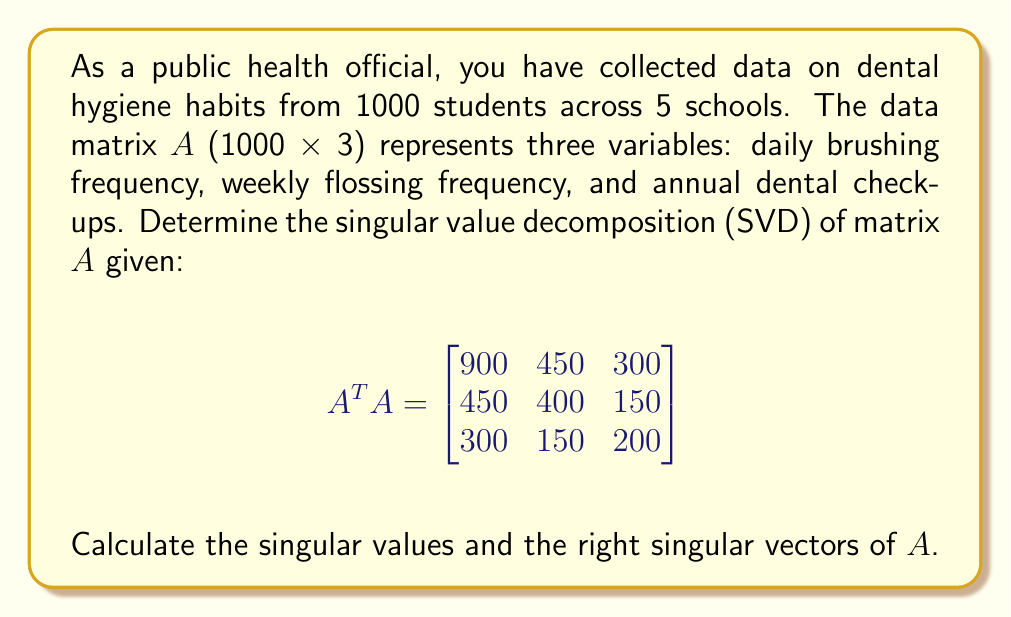Could you help me with this problem? To find the singular value decomposition of $A$, we need to follow these steps:

1) The singular values of $A$ are the square roots of the eigenvalues of $A^T A$.

2) Find the eigenvalues of $A^T A$ by solving the characteristic equation:
   $$\det(A^T A - \lambda I) = 0$$

3) Expand the determinant:
   $$\begin{vmatrix}
   900-\lambda & 450 & 300 \\
   450 & 400-\lambda & 150 \\
   300 & 150 & 200-\lambda
   \end{vmatrix} = 0$$

4) This yields the cubic equation:
   $$-\lambda^3 + 1500\lambda^2 - 517500\lambda + 45000000 = 0$$

5) Solving this equation (using a computer algebra system) gives the eigenvalues:
   $$\lambda_1 = 1200, \lambda_2 = 250, \lambda_3 = 50$$

6) The singular values are the square roots of these eigenvalues:
   $$\sigma_1 = \sqrt{1200} \approx 34.64, \sigma_2 = \sqrt{250} \approx 15.81, \sigma_3 = \sqrt{50} \approx 7.07$$

7) To find the right singular vectors, we need to find the eigenvectors of $A^T A$ for each eigenvalue.

8) For $\lambda_1 = 1200$:
   $$(A^T A - 1200I)\mathbf{v}_1 = \mathbf{0}$$
   Solving this gives: $\mathbf{v}_1 \approx [0.8944, 0.4472, 0.2981]^T$

9) For $\lambda_2 = 250$:
   $$(A^T A - 250I)\mathbf{v}_2 = \mathbf{0}$$
   Solving this gives: $\mathbf{v}_2 \approx [-0.4364, 0.8729, -0.2182]^T$

10) For $\lambda_3 = 50$:
    $$(A^T A - 50I)\mathbf{v}_3 = \mathbf{0}$$
    Solving this gives: $\mathbf{v}_3 \approx [0.0954, -0.1907, -0.9272]^T$

These vectors form the columns of the right singular vector matrix $V$.
Answer: Singular values: $\sigma_1 \approx 34.64, \sigma_2 \approx 15.81, \sigma_3 \approx 7.07$
Right singular vectors: $V \approx [0.8944, -0.4364, 0.0954; 0.4472, 0.8729, -0.1907; 0.2981, -0.2182, -0.9272]$ 